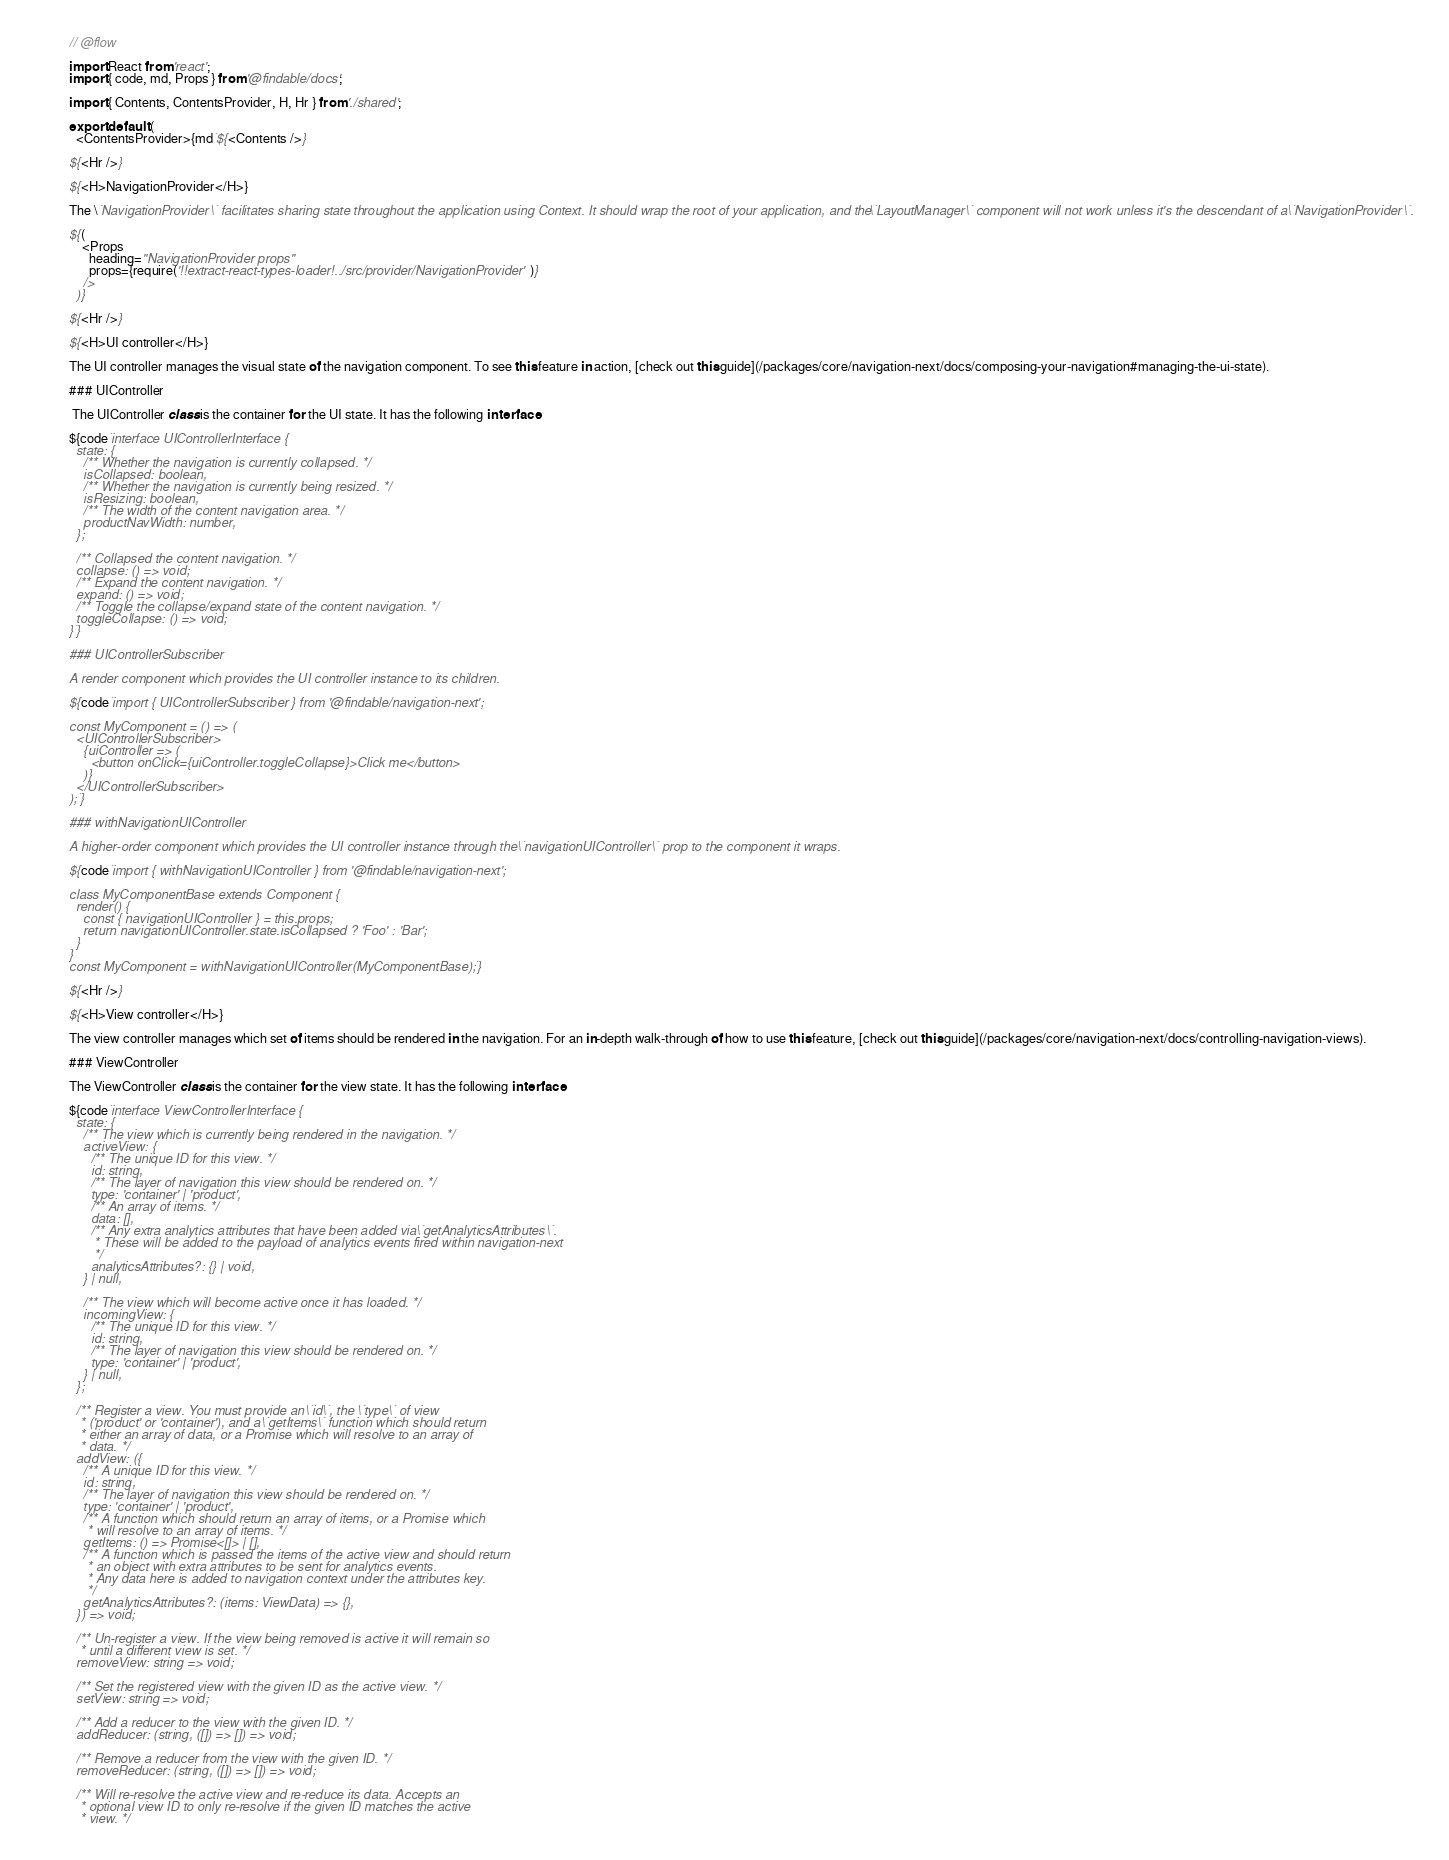<code> <loc_0><loc_0><loc_500><loc_500><_JavaScript_>// @flow

import React from 'react';
import { code, md, Props } from '@findable/docs';

import { Contents, ContentsProvider, H, Hr } from './shared';

export default (
  <ContentsProvider>{md`${<Contents />}

${<Hr />}

${<H>NavigationProvider</H>}

The \`NavigationProvider\` facilitates sharing state throughout the application using Context. It should wrap the root of your application, and the \`LayoutManager\` component will not work unless it's the descendant of a \`NavigationProvider\`.

${(
    <Props
      heading="NavigationProvider props"
      props={require('!!extract-react-types-loader!../src/provider/NavigationProvider')}
    />
  )}

${<Hr />}

${<H>UI controller</H>}

The UI controller manages the visual state of the navigation component. To see this feature in action, [check out this guide](/packages/core/navigation-next/docs/composing-your-navigation#managing-the-ui-state).

### UIController

 The UIController class is the container for the UI state. It has the following interface:

${code`interface UIControllerInterface {
  state: {
    /** Whether the navigation is currently collapsed. */
    isCollapsed: boolean,
    /** Whether the navigation is currently being resized. */
    isResizing: boolean,
    /** The width of the content navigation area. */
    productNavWidth: number,
  };

  /** Collapsed the content navigation. */
  collapse: () => void;
  /** Expand the content navigation. */
  expand: () => void;
  /** Toggle the collapse/expand state of the content navigation. */
  toggleCollapse: () => void;
}`}

### UIControllerSubscriber

A render component which provides the UI controller instance to its children.

${code`import { UIControllerSubscriber } from '@findable/navigation-next';

const MyComponent = () => (
  <UIControllerSubscriber>
    {uiController => (
      <button onClick={uiController.toggleCollapse}>Click me</button>
    )}
  </UIControllerSubscriber>
);`}

### withNavigationUIController

A higher-order component which provides the UI controller instance through the \`navigationUIController\` prop to the component it wraps.

${code`import { withNavigationUIController } from '@findable/navigation-next';

class MyComponentBase extends Component {
  render() {
    const { navigationUIController } = this.props;
    return navigationUIController.state.isCollapsed ? 'Foo' : 'Bar';
  }
}
const MyComponent = withNavigationUIController(MyComponentBase);`}

${<Hr />}

${<H>View controller</H>}

The view controller manages which set of items should be rendered in the navigation. For an in-depth walk-through of how to use this feature, [check out this guide](/packages/core/navigation-next/docs/controlling-navigation-views).

### ViewController

The ViewController class is the container for the view state. It has the following interface:

${code`interface ViewControllerInterface {
  state: {
    /** The view which is currently being rendered in the navigation. */
    activeView: {
      /** The unique ID for this view. */
      id: string,
      /** The layer of navigation this view should be rendered on. */
      type: 'container' | 'product',
      /** An array of items. */
      data: [],
      /** Any extra analytics attributes that have been added via \`getAnalyticsAttributes\`.
       * These will be added to the payload of analytics events fired within navigation-next
       */
      analyticsAttributes?: {} | void,
    } | null,

    /** The view which will become active once it has loaded. */
    incomingView: {
      /** The unique ID for this view. */
      id: string,
      /** The layer of navigation this view should be rendered on. */
      type: 'container' | 'product',
    } | null,
  };

  /** Register a view. You must provide an \`id\`, the \`type\` of view
   * ('product' or 'container'), and a \`getItems\` function which should return
   * either an array of data, or a Promise which will resolve to an array of
   * data. */
  addView: ({
    /** A unique ID for this view. */
    id: string,
    /** The layer of navigation this view should be rendered on. */
    type: 'container' | 'product',
    /** A function which should return an array of items, or a Promise which
     * will resolve to an array of items. */
    getItems: () => Promise<[]> | [],
    /** A function which is passed the items of the active view and should return
     * an object with extra attributes to be sent for analytics events.
     * Any data here is added to navigation context under the attributes key.
     */
    getAnalyticsAttributes?: (items: ViewData) => {},
  }) => void;

  /** Un-register a view. If the view being removed is active it will remain so
   * until a different view is set. */
  removeView: string => void;

  /** Set the registered view with the given ID as the active view. */
  setView: string => void;

  /** Add a reducer to the view with the given ID. */
  addReducer: (string, ([]) => []) => void;

  /** Remove a reducer from the view with the given ID. */
  removeReducer: (string, ([]) => []) => void;

  /** Will re-resolve the active view and re-reduce its data. Accepts an
   * optional view ID to only re-resolve if the given ID matches the active
   * view. */</code> 